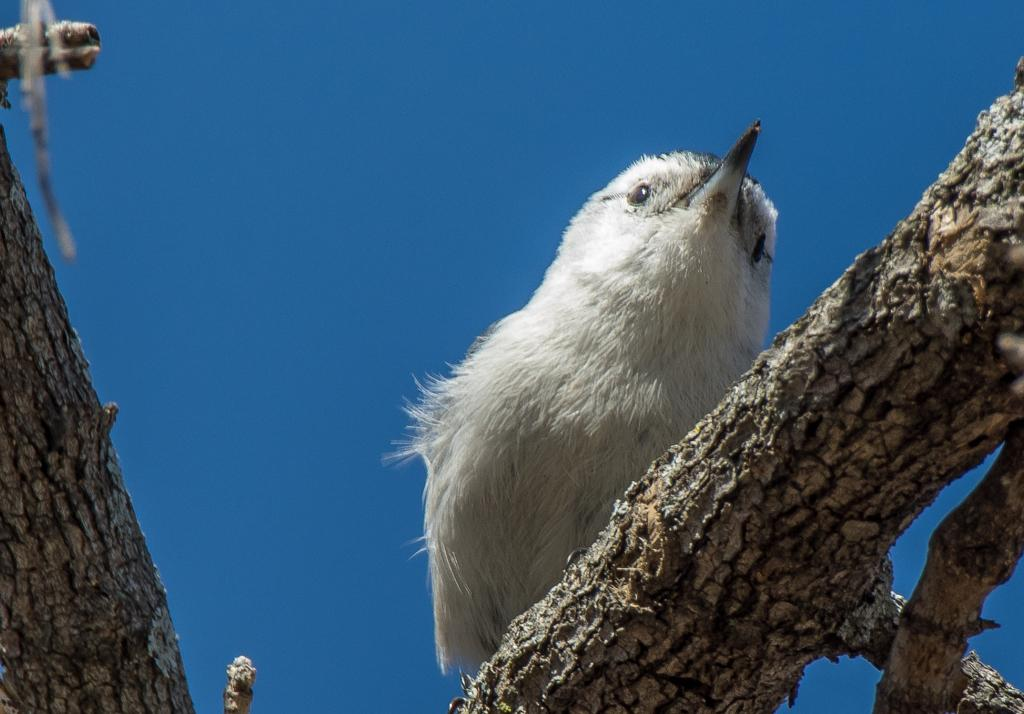What type of animal can be seen in the image? There is a bird in the image. Where is the bird located? The bird is on the branch of a tree. What can be seen in the background of the image? The sky is visible in the background of the image. What type of grass is growing on the bird's head in the image? There is no grass growing on the bird's head in the image; the bird is on a branch of a tree. 